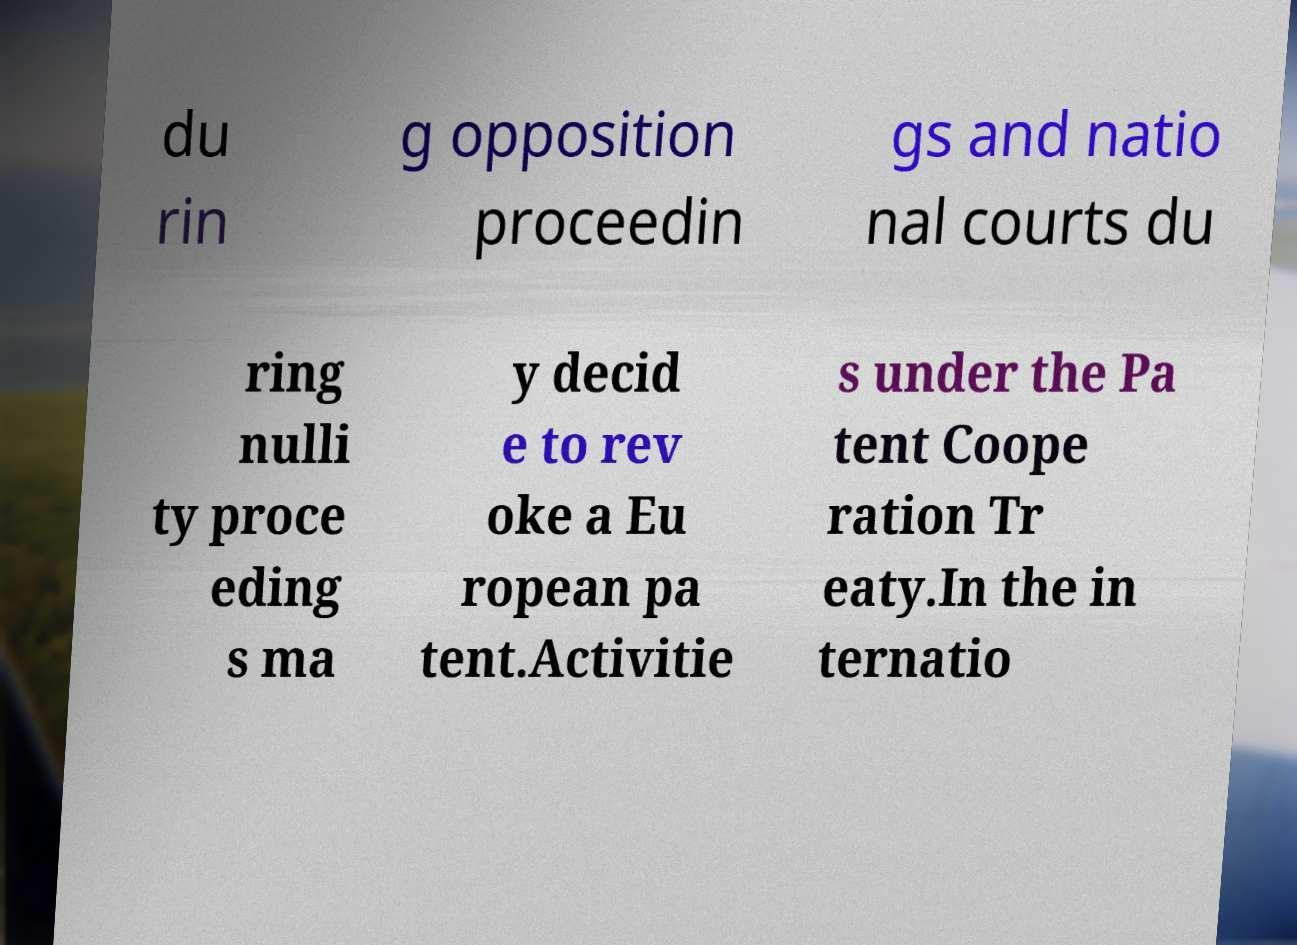Please identify and transcribe the text found in this image. du rin g opposition proceedin gs and natio nal courts du ring nulli ty proce eding s ma y decid e to rev oke a Eu ropean pa tent.Activitie s under the Pa tent Coope ration Tr eaty.In the in ternatio 